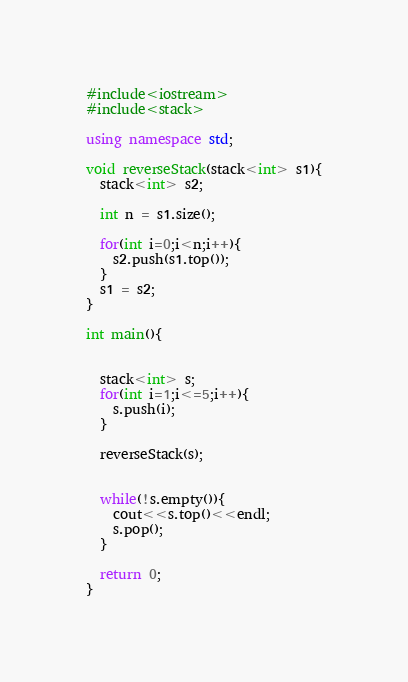<code> <loc_0><loc_0><loc_500><loc_500><_C++_>#include<iostream>
#include<stack>

using namespace std;

void reverseStack(stack<int> s1){
  stack<int> s2;

  int n = s1.size();

  for(int i=0;i<n;i++){
    s2.push(s1.top());
  }
  s1 = s2;  
}

int main(){


  stack<int> s;
  for(int i=1;i<=5;i++){
    s.push(i);
  }

  reverseStack(s);     


  while(!s.empty()){
    cout<<s.top()<<endl;
    s.pop();
  }

  return 0;
}</code> 